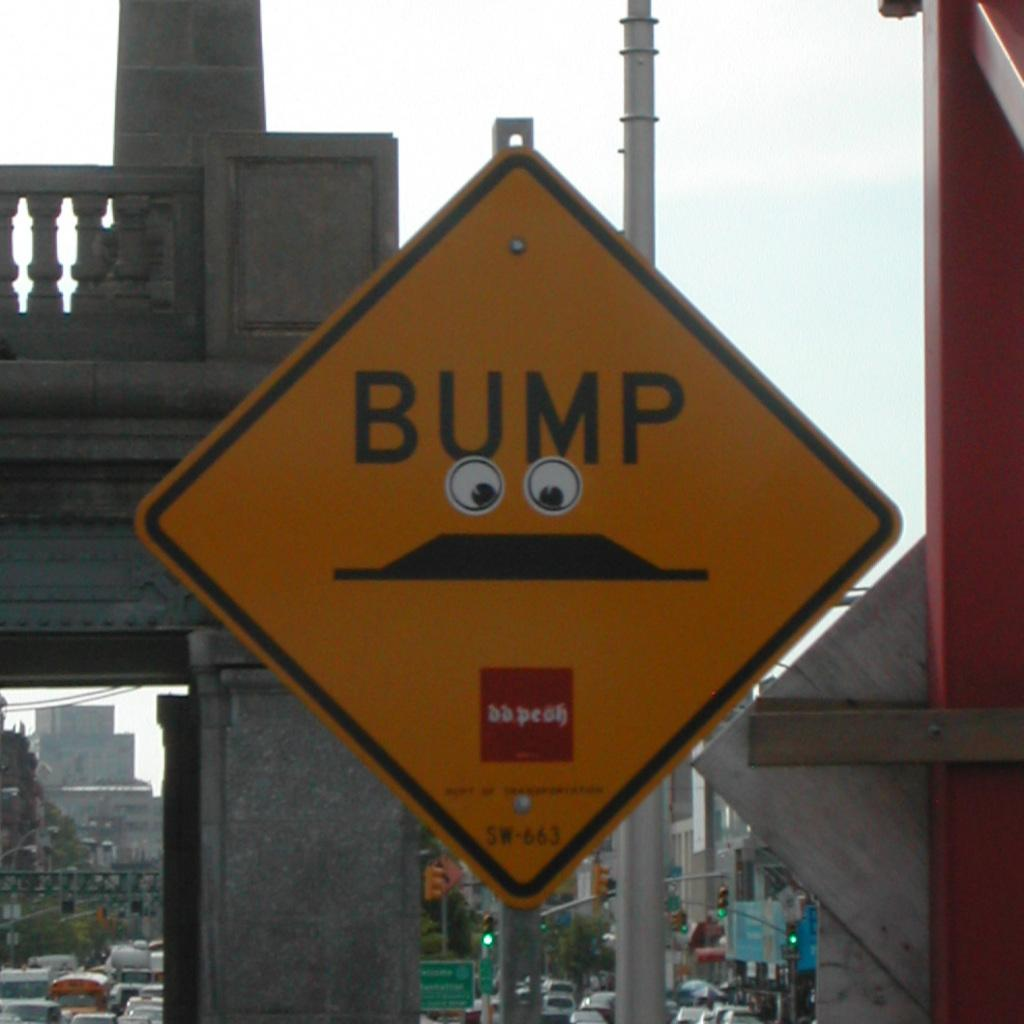What is located at the front of the image? There is a board in the front of the image. What can be seen in the background of the image? In the background of the image, there are boards, poles, signal lights, buildings, trees, light poles, vehicles, the sky, and a beam. How many boards are visible in the image? There is one board in the front and multiple boards in the background, so there are at least two boards visible. What type of objects are present in the background of the image? In the background of the image, there are boards, poles, signal lights, buildings, trees, light poles, vehicles, and a beam. What type of iron is being used to create mist in the image? There is no iron or mist present in the image. How does the tank affect the signal lights in the image? There is no tank present in the image, so it cannot affect the signal lights. 